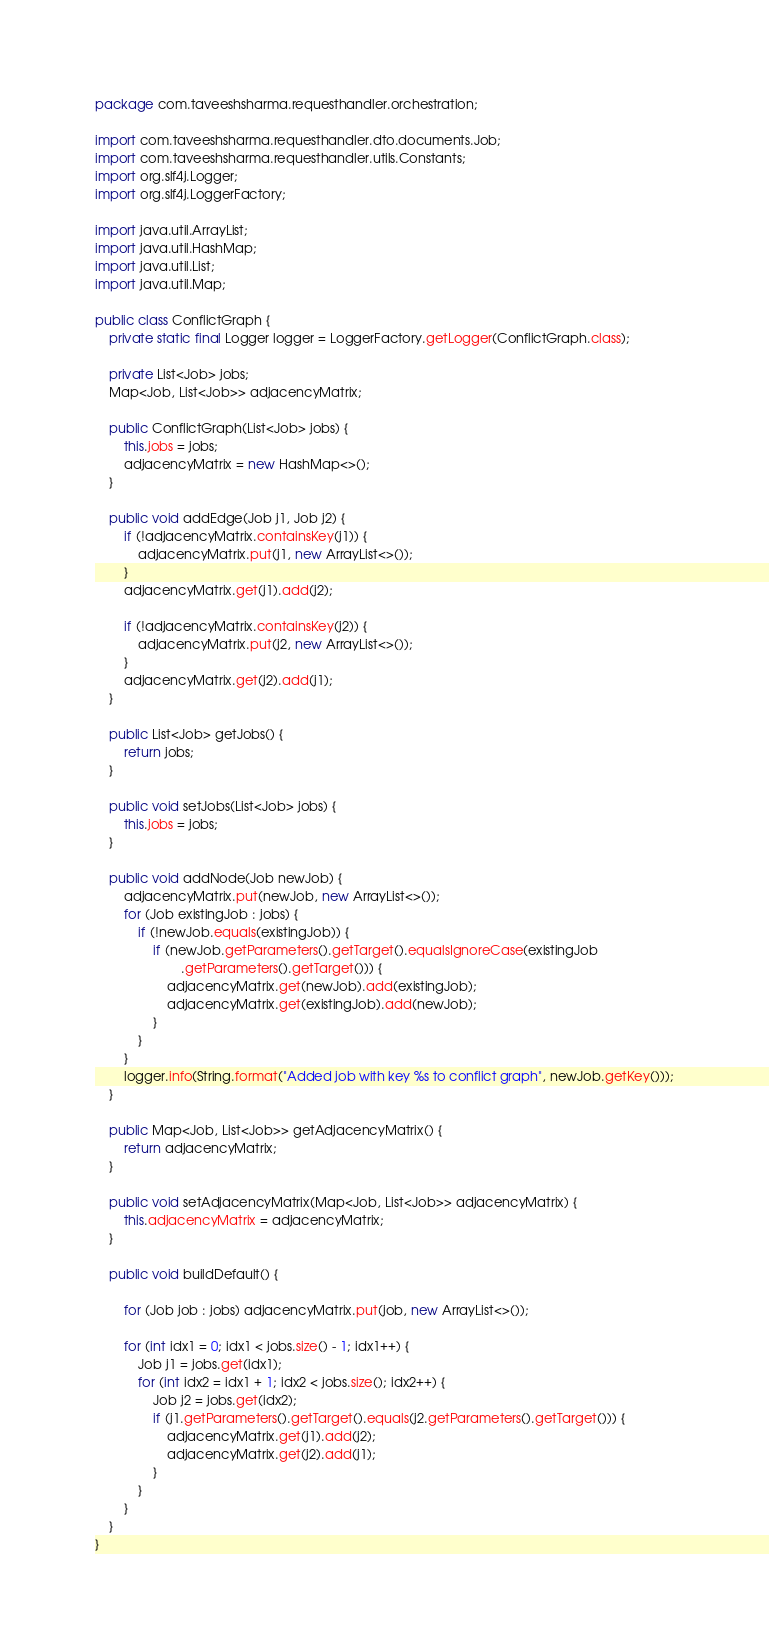Convert code to text. <code><loc_0><loc_0><loc_500><loc_500><_Java_>package com.taveeshsharma.requesthandler.orchestration;

import com.taveeshsharma.requesthandler.dto.documents.Job;
import com.taveeshsharma.requesthandler.utils.Constants;
import org.slf4j.Logger;
import org.slf4j.LoggerFactory;

import java.util.ArrayList;
import java.util.HashMap;
import java.util.List;
import java.util.Map;

public class ConflictGraph {
    private static final Logger logger = LoggerFactory.getLogger(ConflictGraph.class);

    private List<Job> jobs;
    Map<Job, List<Job>> adjacencyMatrix;

    public ConflictGraph(List<Job> jobs) {
        this.jobs = jobs;
        adjacencyMatrix = new HashMap<>();
    }

    public void addEdge(Job j1, Job j2) {
        if (!adjacencyMatrix.containsKey(j1)) {
            adjacencyMatrix.put(j1, new ArrayList<>());
        }
        adjacencyMatrix.get(j1).add(j2);

        if (!adjacencyMatrix.containsKey(j2)) {
            adjacencyMatrix.put(j2, new ArrayList<>());
        }
        adjacencyMatrix.get(j2).add(j1);
    }

    public List<Job> getJobs() {
        return jobs;
    }

    public void setJobs(List<Job> jobs) {
        this.jobs = jobs;
    }

    public void addNode(Job newJob) {
        adjacencyMatrix.put(newJob, new ArrayList<>());
        for (Job existingJob : jobs) {
            if (!newJob.equals(existingJob)) {
                if (newJob.getParameters().getTarget().equalsIgnoreCase(existingJob
                        .getParameters().getTarget())) {
                    adjacencyMatrix.get(newJob).add(existingJob);
                    adjacencyMatrix.get(existingJob).add(newJob);
                }
            }
        }
        logger.info(String.format("Added job with key %s to conflict graph", newJob.getKey()));
    }

    public Map<Job, List<Job>> getAdjacencyMatrix() {
        return adjacencyMatrix;
    }

    public void setAdjacencyMatrix(Map<Job, List<Job>> adjacencyMatrix) {
        this.adjacencyMatrix = adjacencyMatrix;
    }

    public void buildDefault() {

        for (Job job : jobs) adjacencyMatrix.put(job, new ArrayList<>());

        for (int idx1 = 0; idx1 < jobs.size() - 1; idx1++) {
            Job j1 = jobs.get(idx1);
            for (int idx2 = idx1 + 1; idx2 < jobs.size(); idx2++) {
                Job j2 = jobs.get(idx2);
                if (j1.getParameters().getTarget().equals(j2.getParameters().getTarget())) {
                    adjacencyMatrix.get(j1).add(j2);
                    adjacencyMatrix.get(j2).add(j1);
                }
            }
        }
    }
}
</code> 